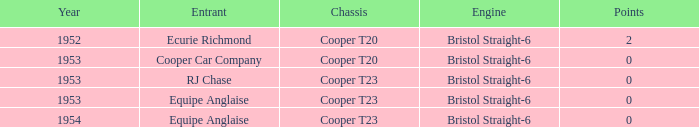Which of the biggest points numbers had a year more recent than 1953? 0.0. 